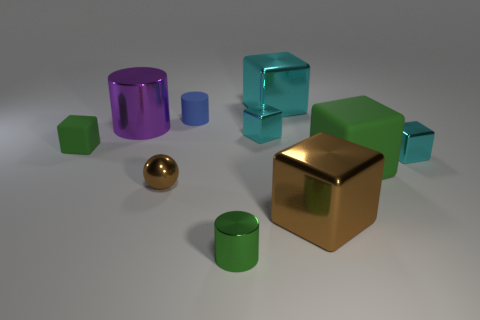Subtract all green cylinders. How many cylinders are left? 2 Subtract all purple cylinders. How many cylinders are left? 2 Subtract all balls. How many objects are left? 9 Subtract 1 brown spheres. How many objects are left? 9 Subtract 2 cylinders. How many cylinders are left? 1 Subtract all cyan blocks. Subtract all cyan cylinders. How many blocks are left? 3 Subtract all purple blocks. How many blue spheres are left? 0 Subtract all gray metallic cylinders. Subtract all small cubes. How many objects are left? 7 Add 7 tiny brown things. How many tiny brown things are left? 8 Add 6 red matte cylinders. How many red matte cylinders exist? 6 